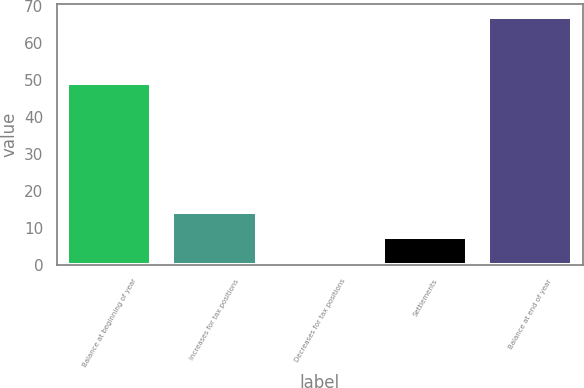<chart> <loc_0><loc_0><loc_500><loc_500><bar_chart><fcel>Balance at beginning of year<fcel>Increases for tax positions<fcel>Decreases for tax positions<fcel>Settlements<fcel>Balance at end of year<nl><fcel>49<fcel>14.2<fcel>1<fcel>7.6<fcel>67<nl></chart> 